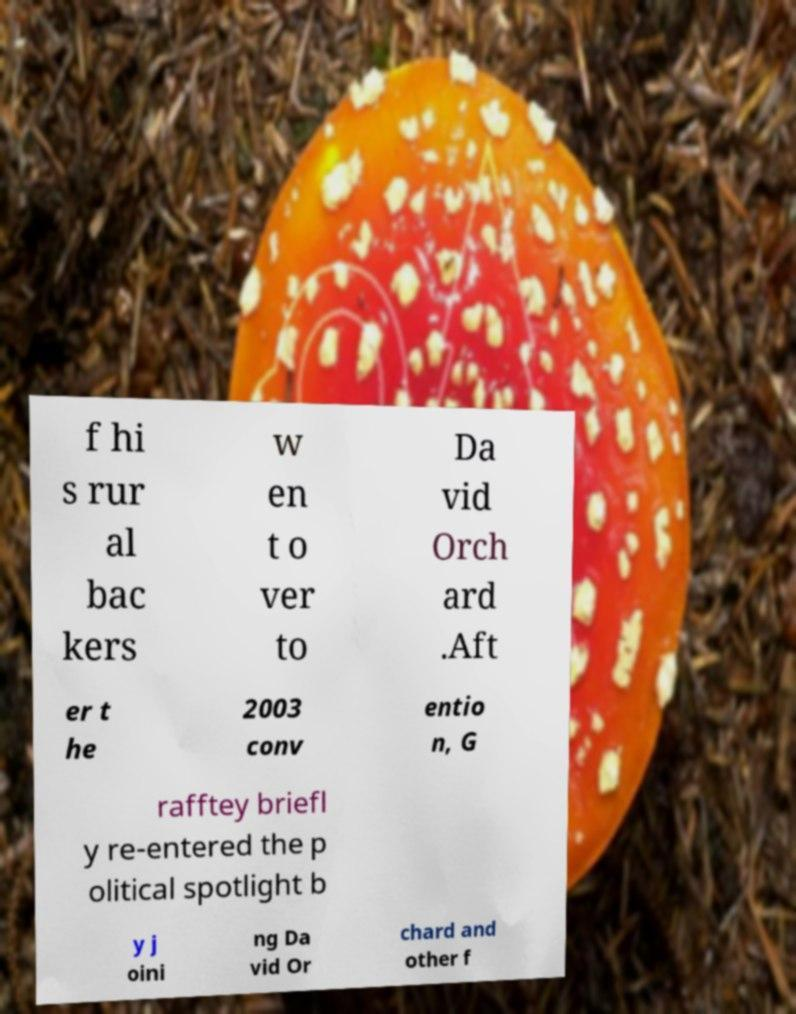Can you accurately transcribe the text from the provided image for me? f hi s rur al bac kers w en t o ver to Da vid Orch ard .Aft er t he 2003 conv entio n, G rafftey briefl y re-entered the p olitical spotlight b y j oini ng Da vid Or chard and other f 